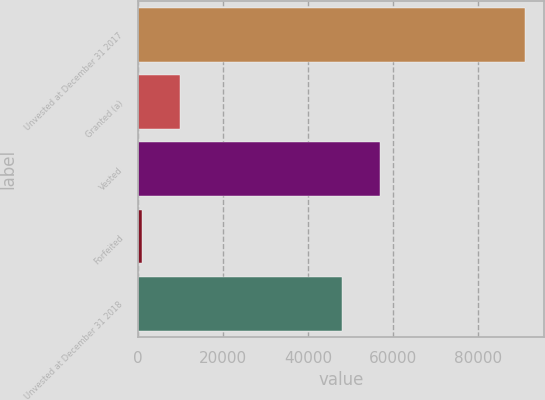<chart> <loc_0><loc_0><loc_500><loc_500><bar_chart><fcel>Unvested at December 31 2017<fcel>Granted (a)<fcel>Vested<fcel>Forfeited<fcel>Unvested at December 31 2018<nl><fcel>91000<fcel>10000<fcel>57000<fcel>1000<fcel>48000<nl></chart> 